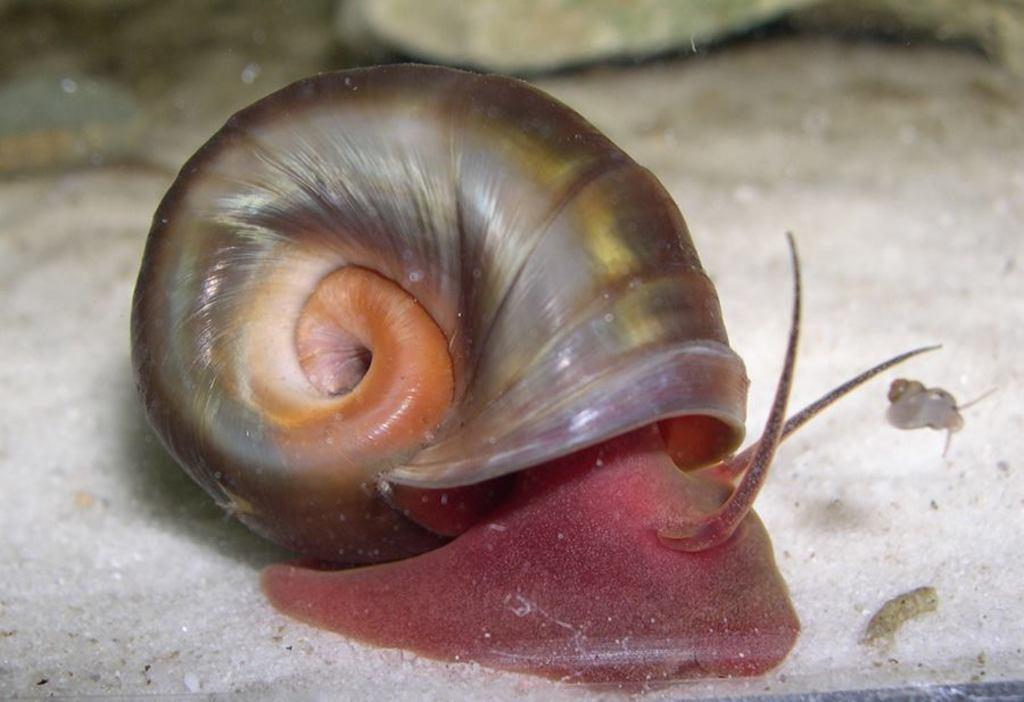What type of animal is present in the image? There is a snail in the image. What type of zephyr is the snail wearing in the image? There is no mention of a zephyr in the image, and snails do not wear clothing. 